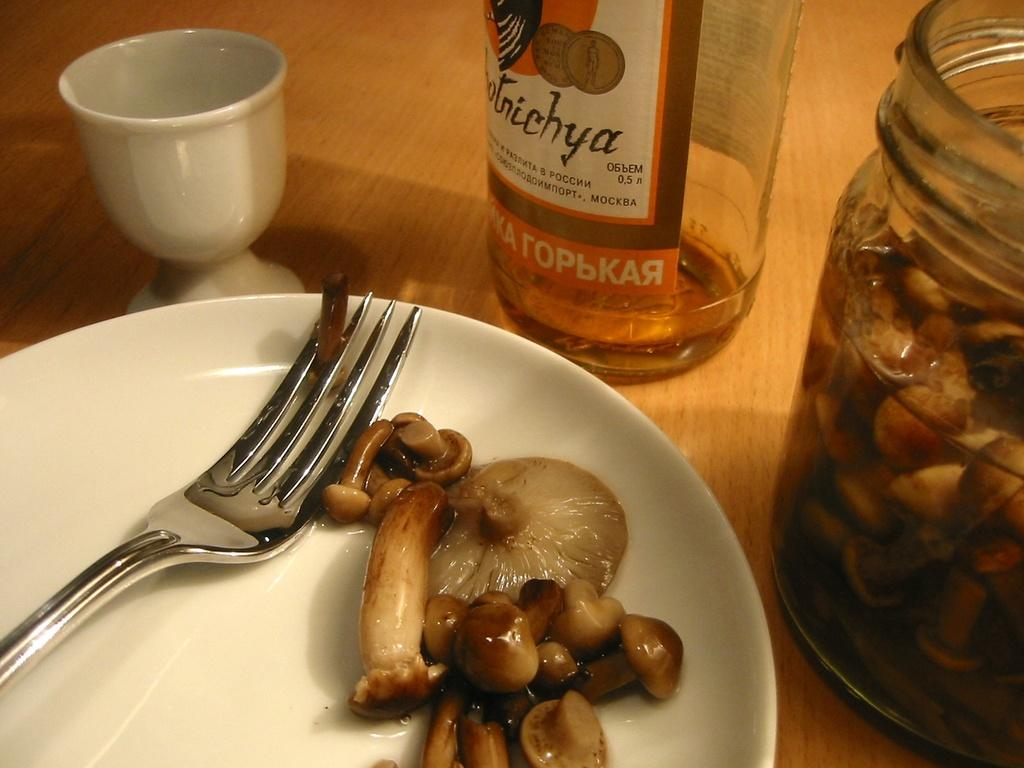What piece of furniture is present in the image? There is a table in the image. What is placed on the table? There is a cup, a bottle, a jar with mushrooms and sauce, a plate with a fork, and mushrooms on the plate. Can you describe the contents of the jar? The jar contains mushrooms and sauce. What utensil is present on the plate? There is a fork on the plate. What type of guide is present in the image to help with decision-making? There is no guide present in the image, nor is there any indication of decision-making. 